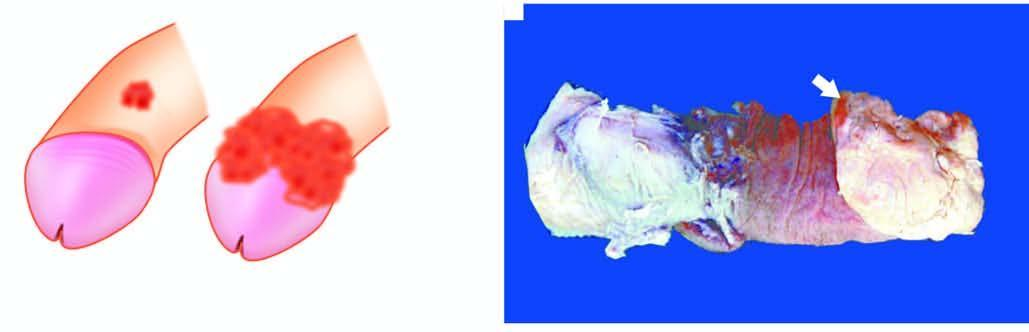does large cystic spaces lined by the flattened endothelial cells and containing lymph show a cauliflower growth on the coronal sulcus?
Answer the question using a single word or phrase. No 